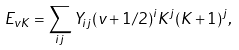<formula> <loc_0><loc_0><loc_500><loc_500>E _ { v K } = \sum _ { i j } Y _ { i j } ( v + 1 / 2 ) ^ { i } K ^ { j } ( K + 1 ) ^ { j } ,</formula> 